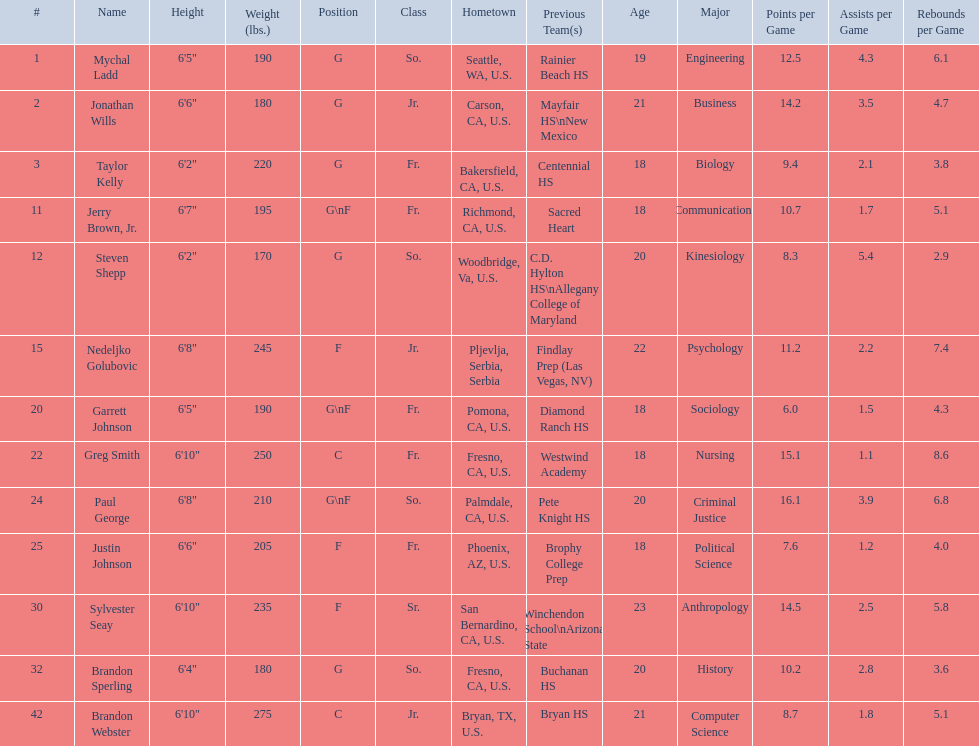Who played during the 2009-10 fresno state bulldogs men's basketball team? Mychal Ladd, Jonathan Wills, Taylor Kelly, Jerry Brown, Jr., Steven Shepp, Nedeljko Golubovic, Garrett Johnson, Greg Smith, Paul George, Justin Johnson, Sylvester Seay, Brandon Sperling, Brandon Webster. What was the position of each player? G, G, G, G\nF, G, F, G\nF, C, G\nF, F, F, G, C. And how tall were they? 6'5", 6'6", 6'2", 6'7", 6'2", 6'8", 6'5", 6'10", 6'8", 6'6", 6'10", 6'4", 6'10". Of these players, who was the shortest forward player? Justin Johnson. 